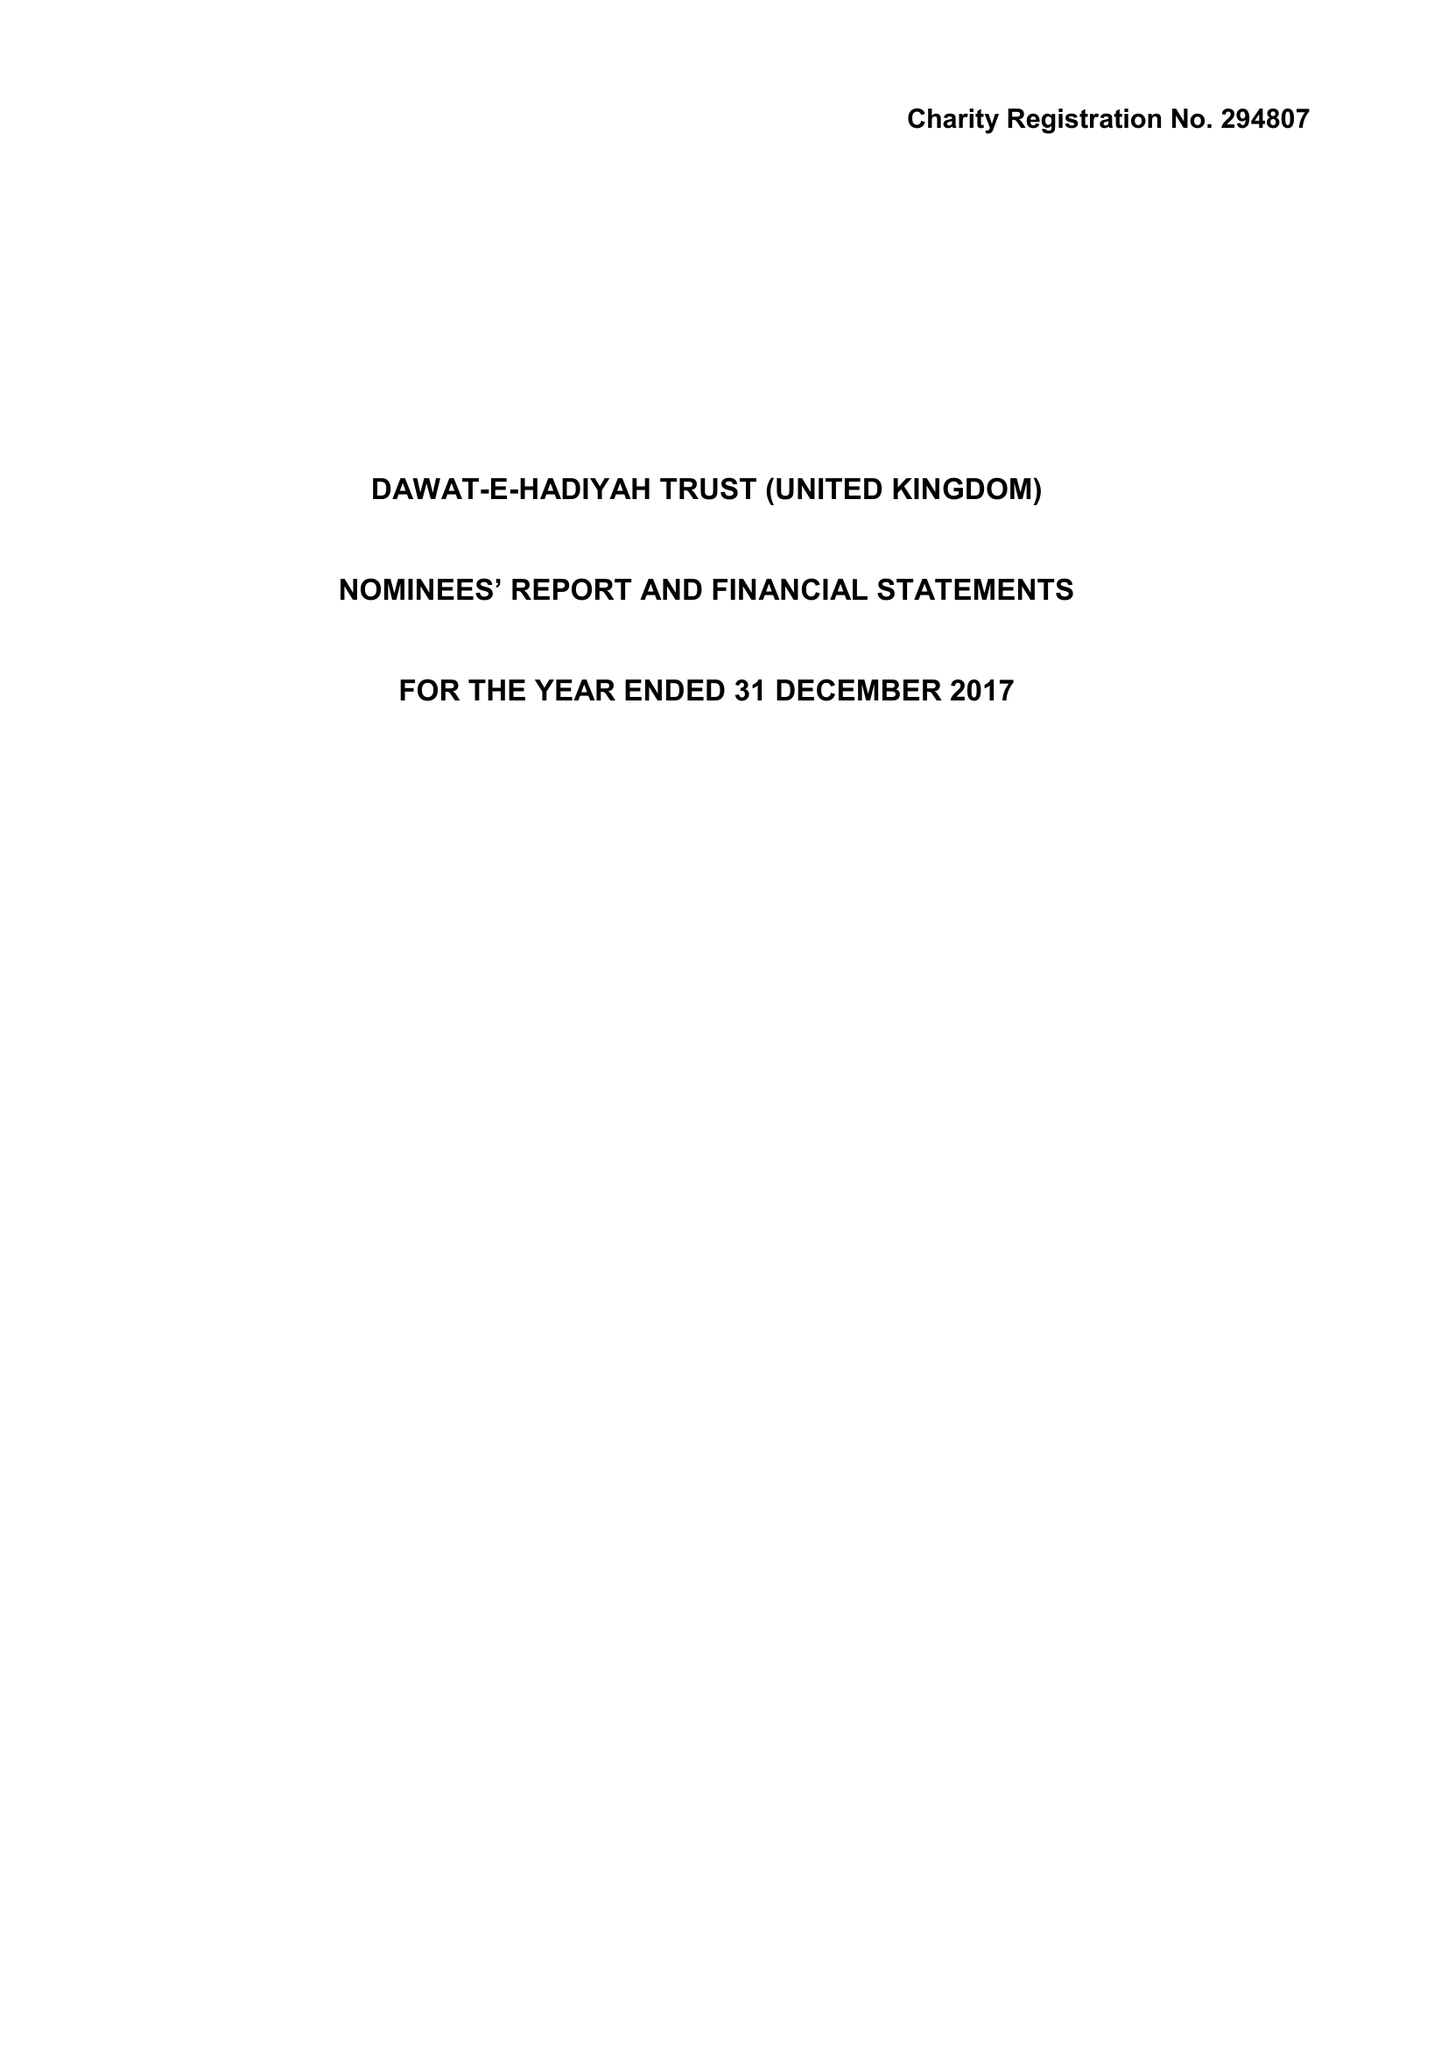What is the value for the address__postcode?
Answer the question using a single word or phrase. UB5 6AG 